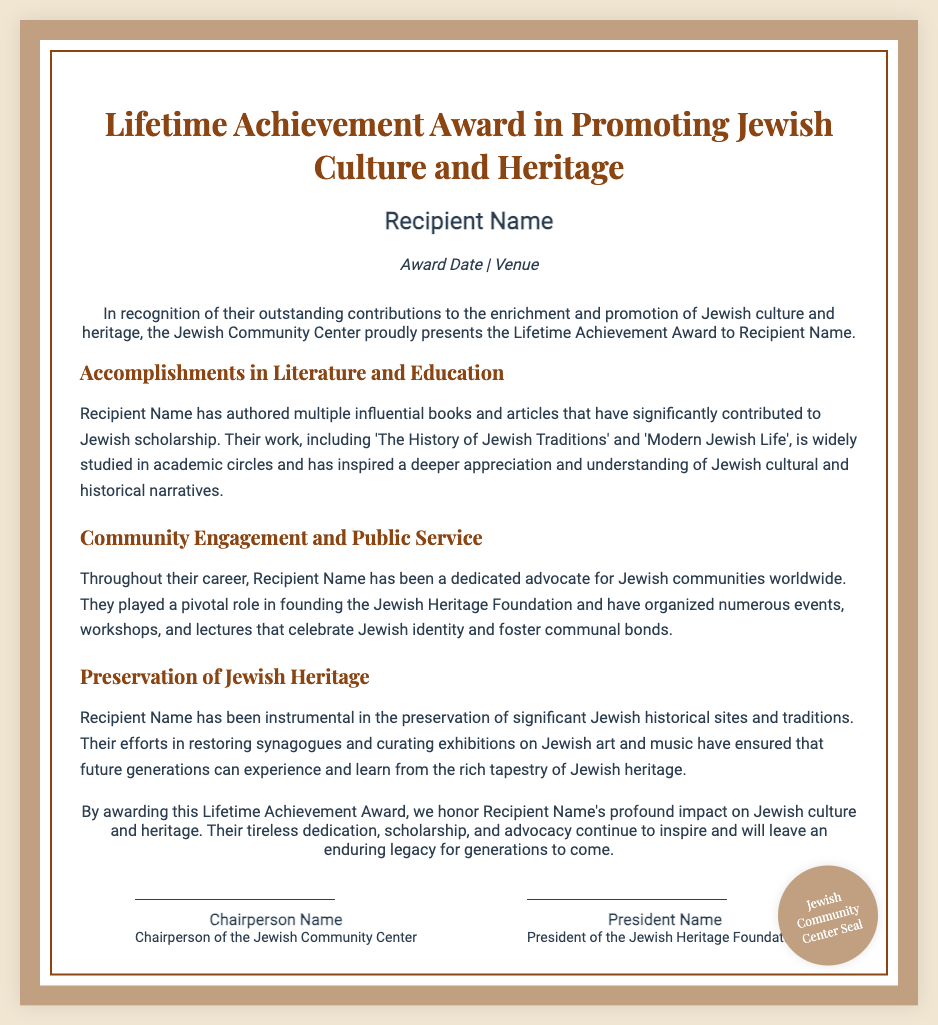What is the title of the award? The title of the award is the Lifetime Achievement Award in Promoting Jewish Culture and Heritage
Answer: Lifetime Achievement Award in Promoting Jewish Culture and Heritage Who is the recipient of the award? The recipient's name is specified in the diploma document.
Answer: Recipient Name What is the award date? The award date is mentioned alongside the venue in the diploma document.
Answer: Award Date What is one of the books authored by the recipient? The diploma lists notable works authored by the recipient, one being 'The History of Jewish Traditions'.
Answer: The History of Jewish Traditions What organization did the recipient help found? The document states that the recipient played a role in founding a specific organization.
Answer: Jewish Heritage Foundation What is the purpose of the Lifetime Achievement Award? The purpose is to honor individuals for their contributions to a specific cultural aspect.
Answer: To recognize outstanding contributions to the enrichment and promotion of Jewish culture and heritage Who signed the diploma as Chairperson? The diploma provides the name of the individual who signed as Chairperson.
Answer: Chairperson Name What is mentioned about the preservation efforts of the recipient? The document details the recipient's contributions to preserving historical and cultural elements.
Answer: Preservation of significant Jewish historical sites and traditions How is the layout of the diploma described? The layout includes specifics about its design and style, which are outlined in the document.
Answer: Featuring a border and a seal 